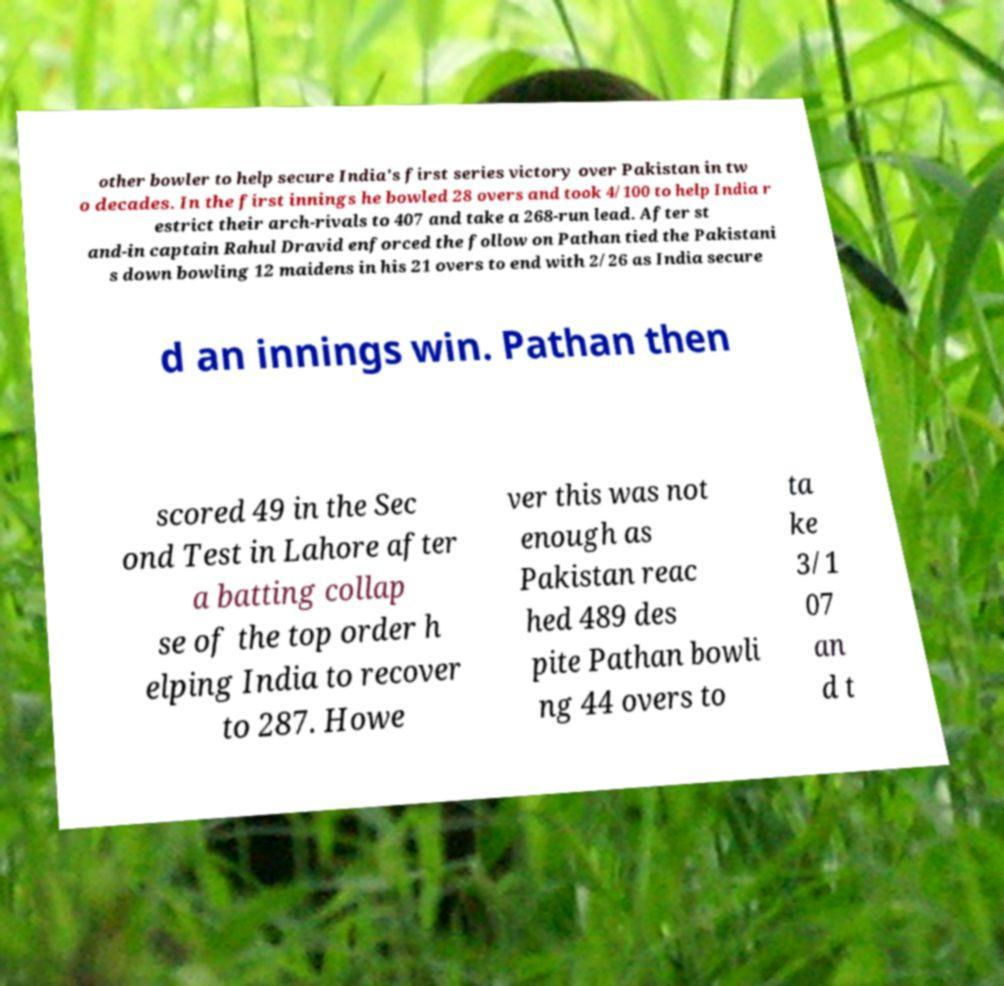What messages or text are displayed in this image? I need them in a readable, typed format. other bowler to help secure India's first series victory over Pakistan in tw o decades. In the first innings he bowled 28 overs and took 4/100 to help India r estrict their arch-rivals to 407 and take a 268-run lead. After st and-in captain Rahul Dravid enforced the follow on Pathan tied the Pakistani s down bowling 12 maidens in his 21 overs to end with 2/26 as India secure d an innings win. Pathan then scored 49 in the Sec ond Test in Lahore after a batting collap se of the top order h elping India to recover to 287. Howe ver this was not enough as Pakistan reac hed 489 des pite Pathan bowli ng 44 overs to ta ke 3/1 07 an d t 